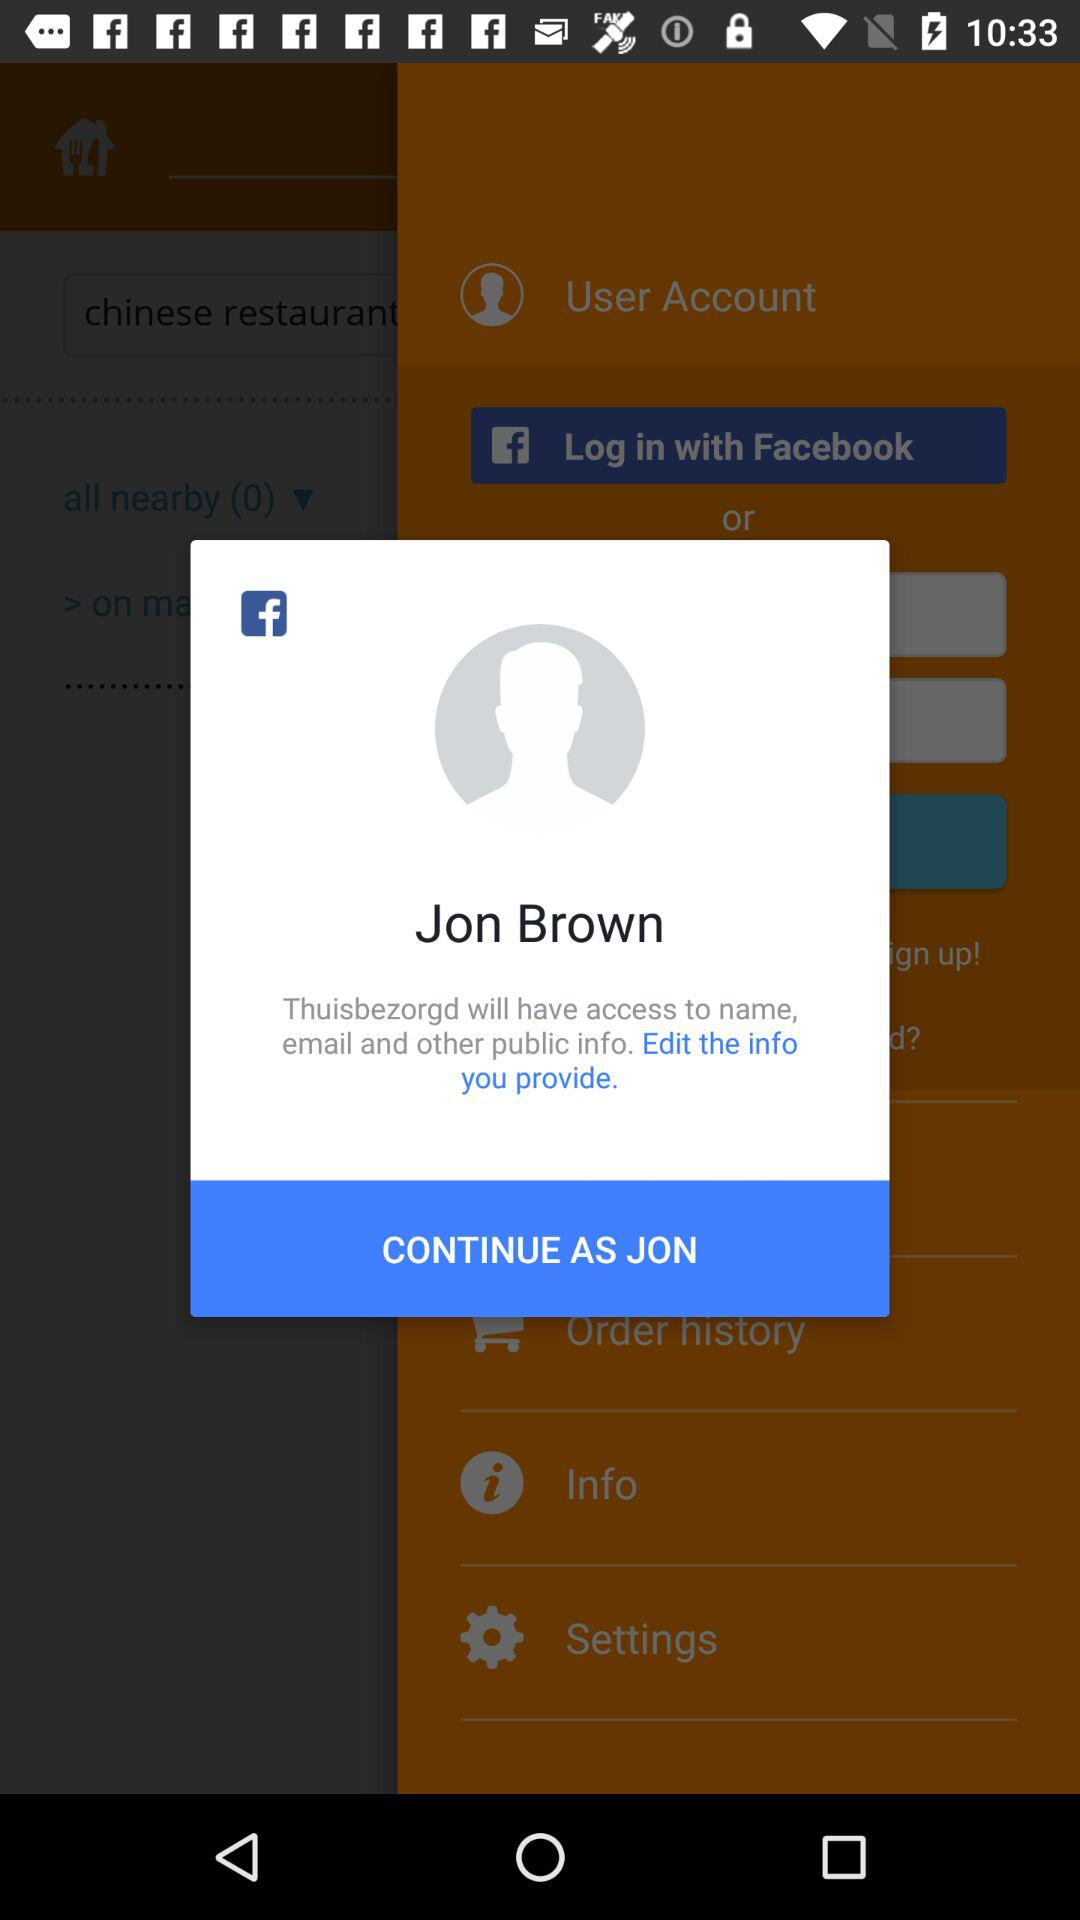To which information will "Thuisbezorgd" have access? "Thuisbezorgd" will have access to name, email and other public information. 